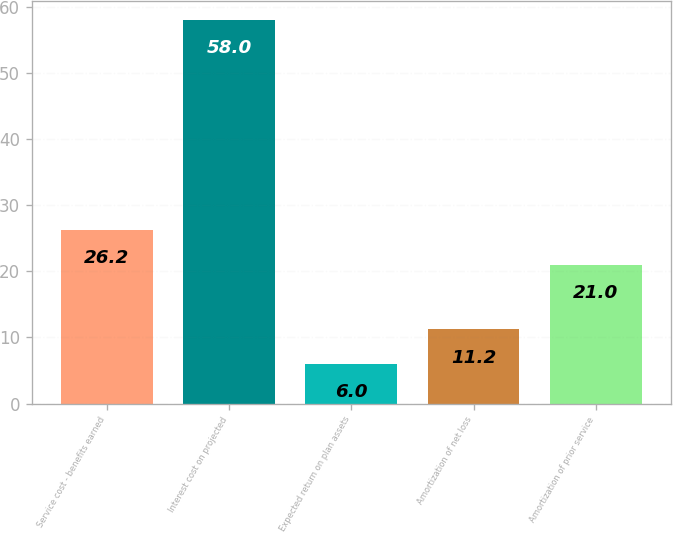Convert chart. <chart><loc_0><loc_0><loc_500><loc_500><bar_chart><fcel>Service cost - benefits earned<fcel>Interest cost on projected<fcel>Expected return on plan assets<fcel>Amortization of net loss<fcel>Amortization of prior service<nl><fcel>26.2<fcel>58<fcel>6<fcel>11.2<fcel>21<nl></chart> 